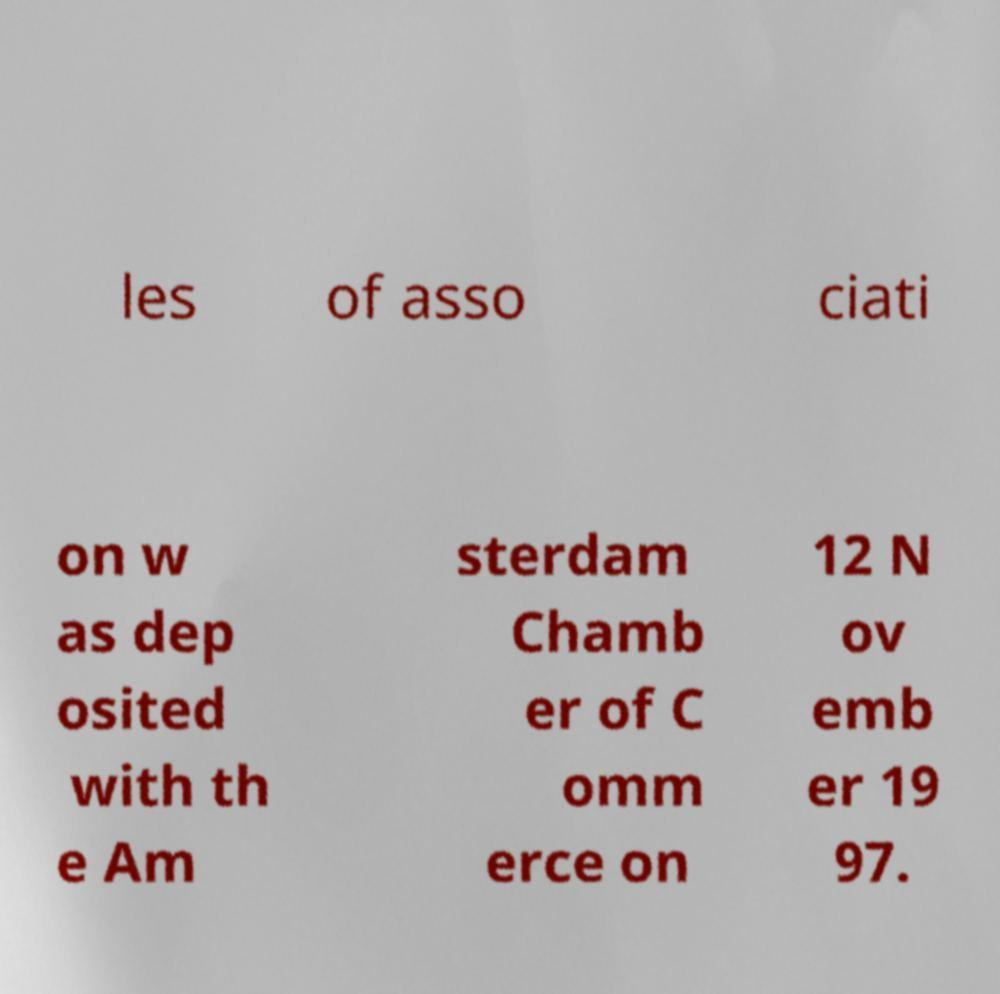Could you assist in decoding the text presented in this image and type it out clearly? les of asso ciati on w as dep osited with th e Am sterdam Chamb er of C omm erce on 12 N ov emb er 19 97. 